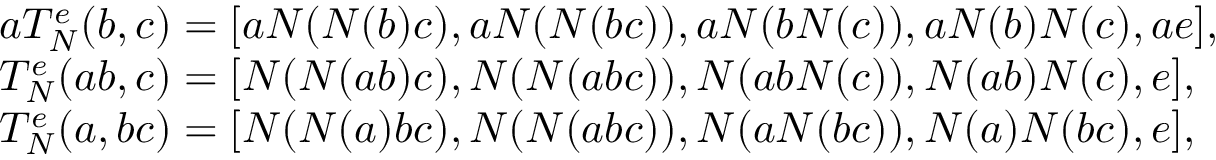<formula> <loc_0><loc_0><loc_500><loc_500>\begin{array} { r l } & { a T _ { N } ^ { e } ( b , c ) = [ a N ( N ( b ) c ) , a N ( N ( b c ) ) , a N ( b N ( c ) ) , a N ( b ) N ( c ) , a e ] , } \\ & { T _ { N } ^ { e } ( a b , c ) = [ N ( N ( a b ) c ) , N ( N ( a b c ) ) , N ( a b N ( c ) ) , N ( a b ) N ( c ) , e ] , } \\ & { T _ { N } ^ { e } ( a , b c ) = [ N ( N ( a ) b c ) , N ( N ( a b c ) ) , N ( a N ( b c ) ) , N ( a ) N ( b c ) , e ] , } \end{array}</formula> 